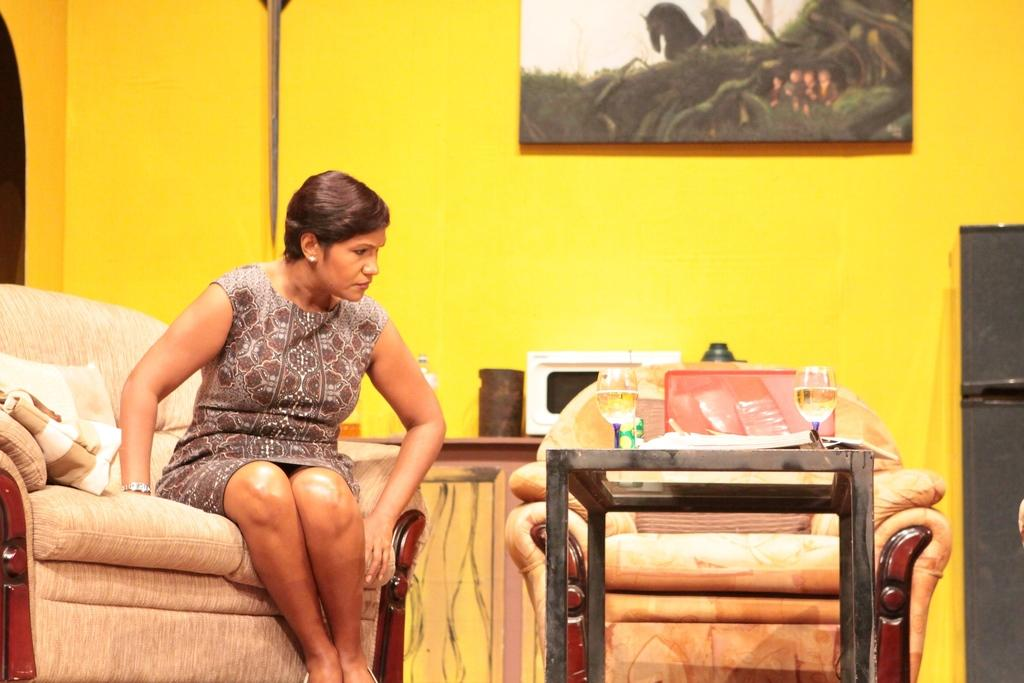What is the woman in the image sitting on? The woman is sitting on a couch. What features does the couch have? The couch has pillows and a blanket. What color is the wall behind the woman? The wall behind the woman is yellow. What is placed on the yellow wall? There is a photo frame placed on the yellow wall. What type of bread is being used as a decoration on the couch? There is no bread present in the image, and the couch is not being used as a decoration. 